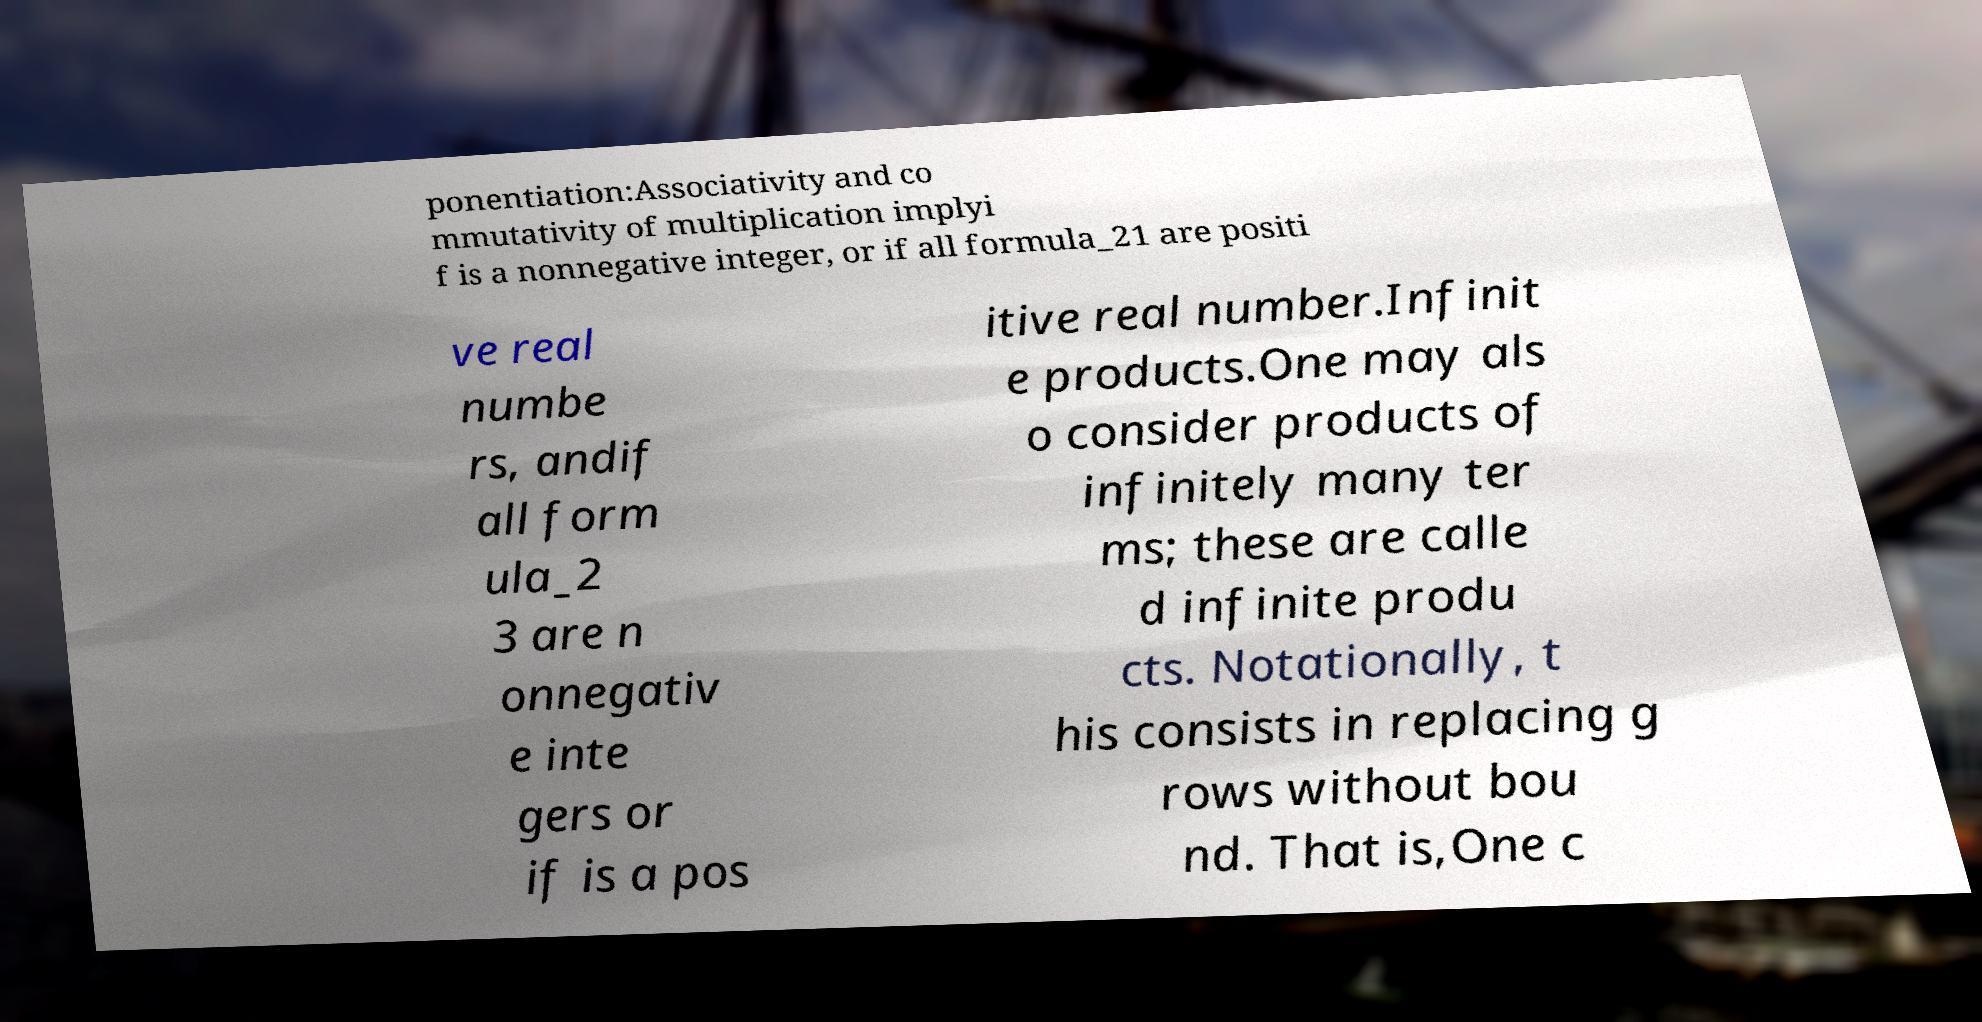Please read and relay the text visible in this image. What does it say? ponentiation:Associativity and co mmutativity of multiplication implyi f is a nonnegative integer, or if all formula_21 are positi ve real numbe rs, andif all form ula_2 3 are n onnegativ e inte gers or if is a pos itive real number.Infinit e products.One may als o consider products of infinitely many ter ms; these are calle d infinite produ cts. Notationally, t his consists in replacing g rows without bou nd. That is,One c 